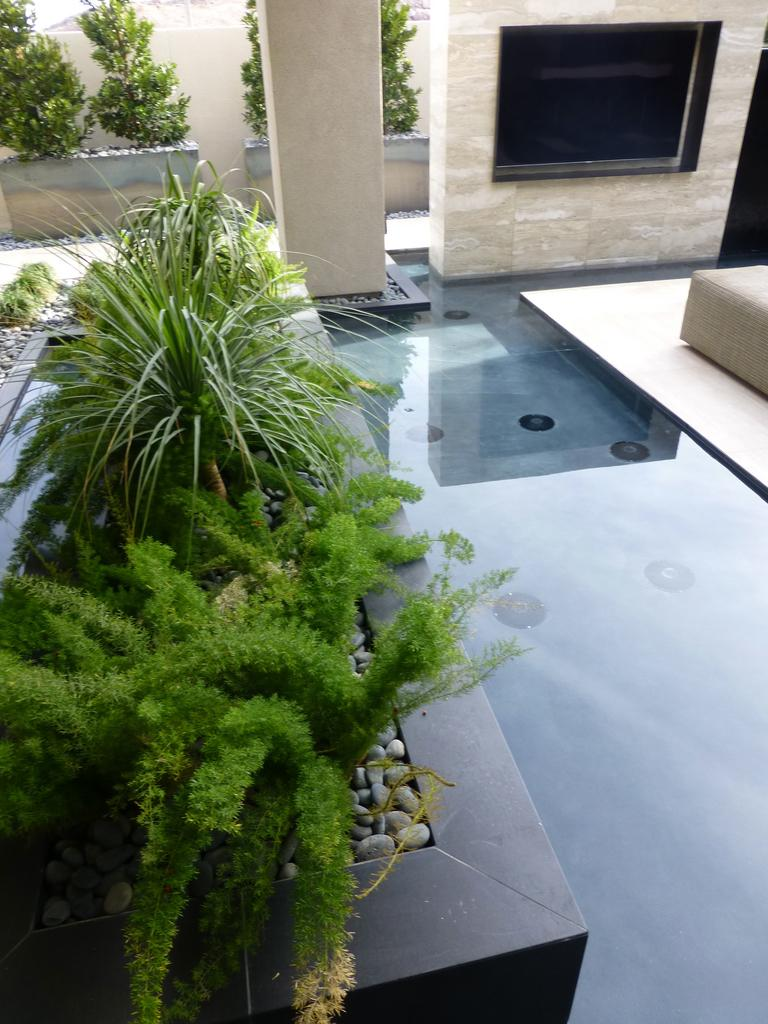What type of area is depicted in the image? There is a seating area in the image. What is located beside the seating area? There is a pillar beside the seating area. What is the color of the pillar? The pillar is of cream color. What can be seen in front of the pillar? There are many plants in front of the pillar. What is located behind the pillar? There are small trees behind the pillar. What type of drug is being sold in the seating area? There is no indication of any drug being sold or present in the image. The image features a seating area with a pillar, plants, and small trees. 